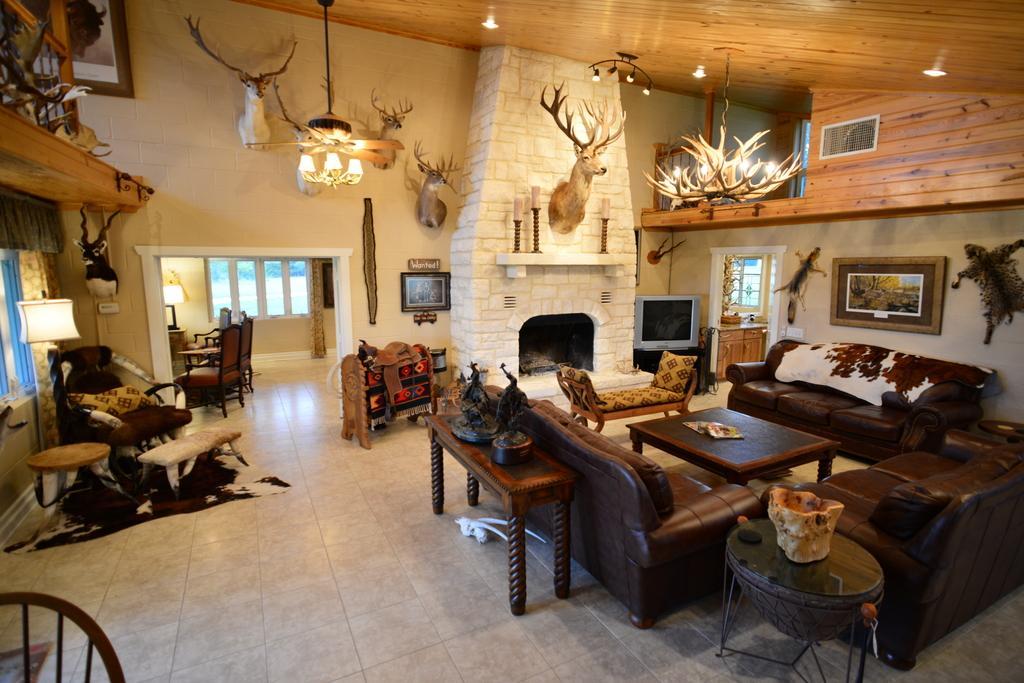How would you summarize this image in a sentence or two? In this image I can see few sofas, chairs and a table. On this wall I can see few frames and some decorations. 